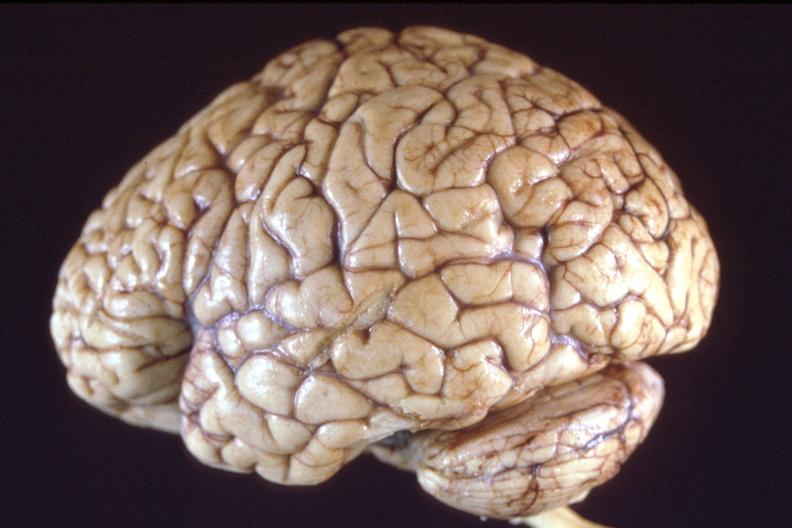s there present?
Answer the question using a single word or phrase. No 